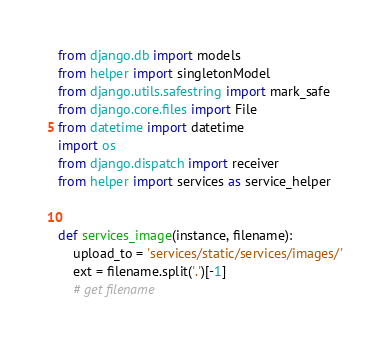Convert code to text. <code><loc_0><loc_0><loc_500><loc_500><_Python_>from django.db import models
from helper import singletonModel
from django.utils.safestring import mark_safe
from django.core.files import File
from datetime import datetime
import os
from django.dispatch import receiver
from helper import services as service_helper


def services_image(instance, filename):
    upload_to = 'services/static/services/images/'
    ext = filename.split('.')[-1]
    # get filename</code> 